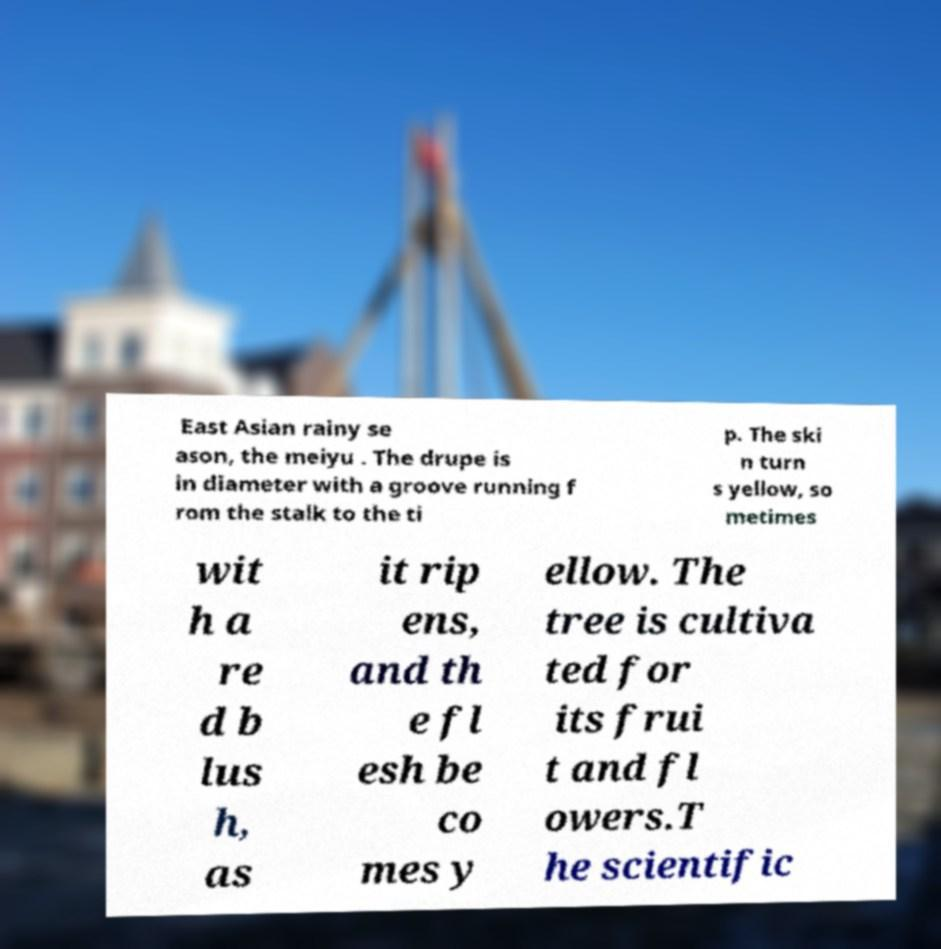For documentation purposes, I need the text within this image transcribed. Could you provide that? East Asian rainy se ason, the meiyu . The drupe is in diameter with a groove running f rom the stalk to the ti p. The ski n turn s yellow, so metimes wit h a re d b lus h, as it rip ens, and th e fl esh be co mes y ellow. The tree is cultiva ted for its frui t and fl owers.T he scientific 